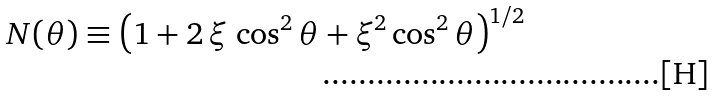Convert formula to latex. <formula><loc_0><loc_0><loc_500><loc_500>N ( \theta ) \equiv \left ( 1 + 2 \, \xi \, \cos ^ { 2 } \theta + \xi ^ { 2 } \cos ^ { 2 } \theta \right ) ^ { 1 / 2 }</formula> 